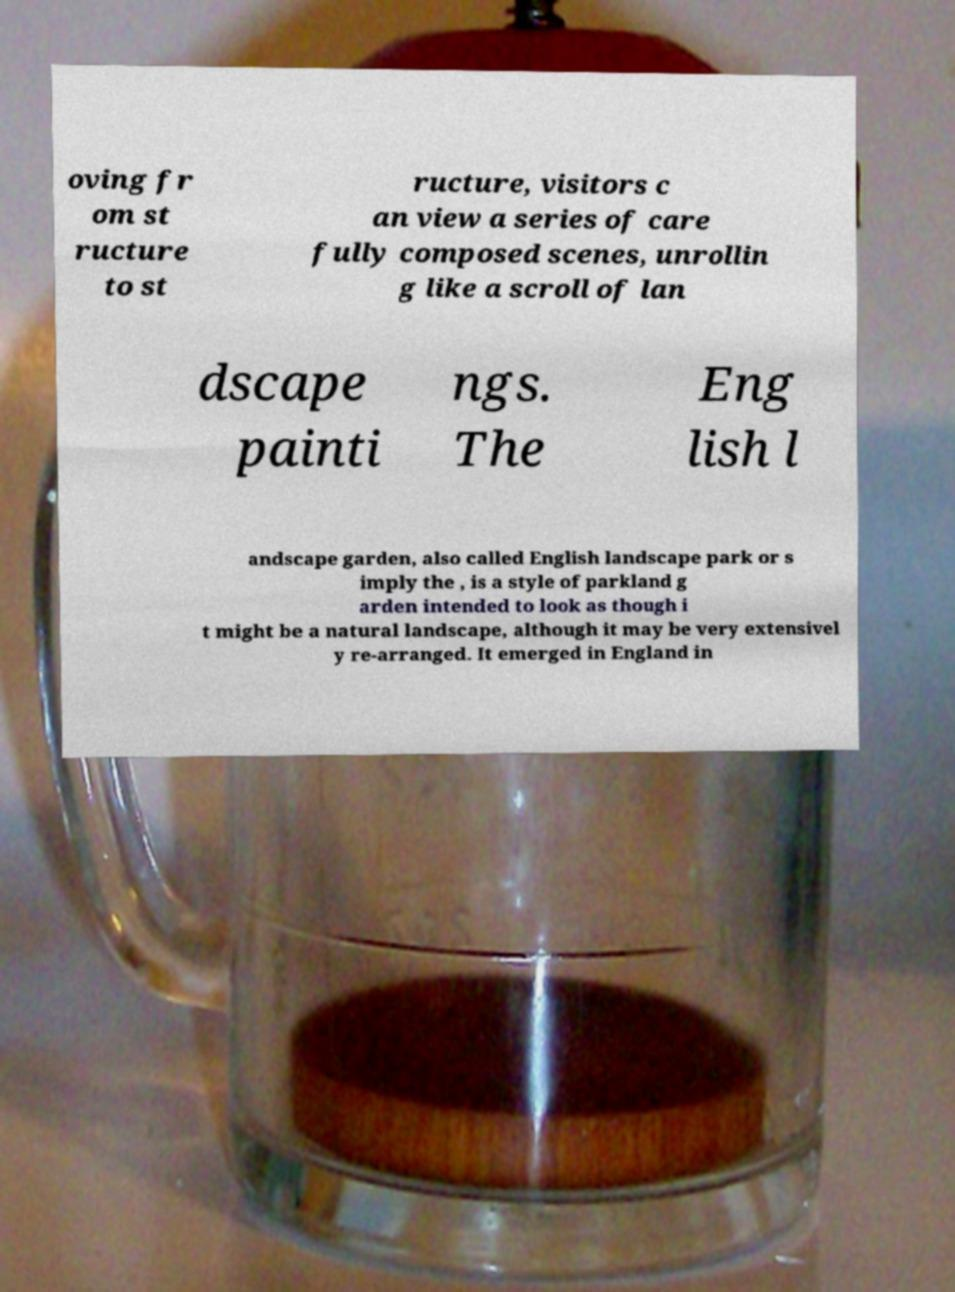What messages or text are displayed in this image? I need them in a readable, typed format. oving fr om st ructure to st ructure, visitors c an view a series of care fully composed scenes, unrollin g like a scroll of lan dscape painti ngs. The Eng lish l andscape garden, also called English landscape park or s imply the , is a style of parkland g arden intended to look as though i t might be a natural landscape, although it may be very extensivel y re-arranged. It emerged in England in 